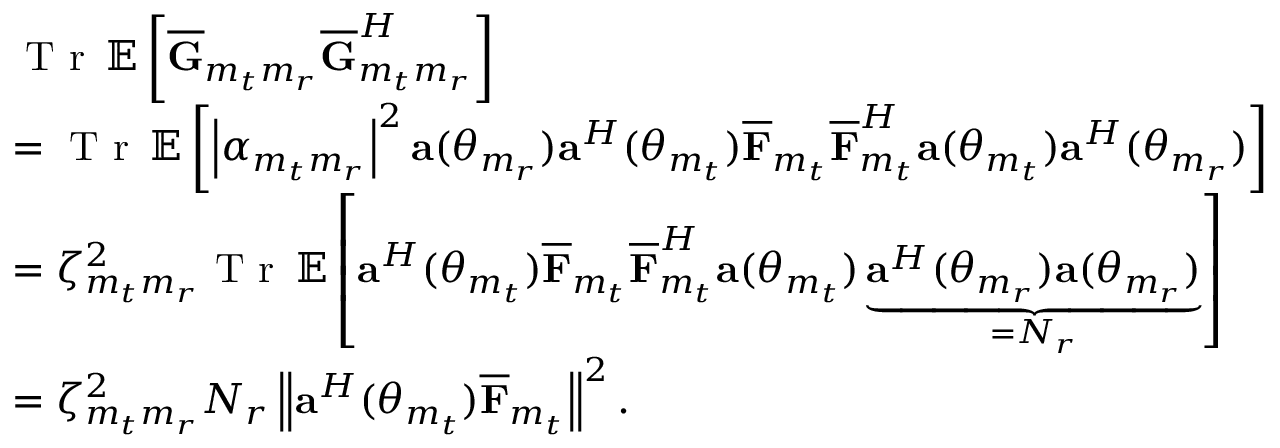Convert formula to latex. <formula><loc_0><loc_0><loc_500><loc_500>\begin{array} { r l } & { T r \, { \mathbb { E } } \left [ \overline { G } _ { m _ { t } m _ { r } } \overline { G } _ { m _ { t } m _ { r } } ^ { H } \right ] } \\ & { = T r \, { \mathbb { E } } \left [ \left | \alpha _ { m _ { t } m _ { r } } \right | ^ { 2 } { a } ( \theta _ { m _ { r } } ) { a } ^ { H } ( \theta _ { m _ { t } } ) \overline { F } _ { m _ { t } } \overline { F } _ { m _ { t } } ^ { H } { a } ( \theta _ { m _ { t } } ) { a } ^ { H } ( \theta _ { m _ { r } } ) \right ] } \\ & { = \zeta _ { m _ { t } m _ { r } } ^ { 2 } T r \, { \mathbb { E } } \left [ { a } ^ { H } ( \theta _ { m _ { t } } ) \overline { F } _ { m _ { t } } \overline { F } _ { m _ { t } } ^ { H } { a } ( \theta _ { m _ { t } } ) \underbrace { { a } ^ { H } ( \theta _ { m _ { r } } ) { a } ( \theta _ { m _ { r } } ) } _ { = N _ { r } } \right ] } \\ & { = \zeta _ { m _ { t } m _ { r } } ^ { 2 } N _ { r } \left \| { a } ^ { H } ( \theta _ { m _ { t } } ) \overline { F } _ { m _ { t } } \right \| ^ { 2 } . } \end{array}</formula> 